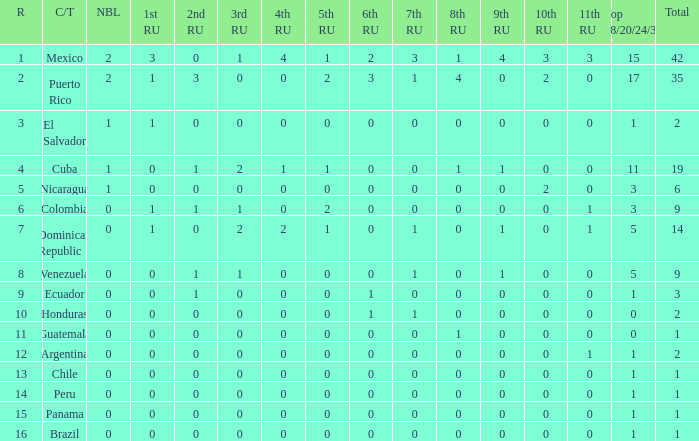What is the average total of the country with a 4th runner-up of 0 and a Nuestra Bellaza Latina less than 0? None. Give me the full table as a dictionary. {'header': ['R', 'C/T', 'NBL', '1st RU', '2nd RU', '3rd RU', '4th RU', '5th RU', '6th RU', '7th RU', '8th RU', '9th RU', '10th RU', '11th RU', 'Top 18/20/24/30', 'Total'], 'rows': [['1', 'Mexico', '2', '3', '0', '1', '4', '1', '2', '3', '1', '4', '3', '3', '15', '42'], ['2', 'Puerto Rico', '2', '1', '3', '0', '0', '2', '3', '1', '4', '0', '2', '0', '17', '35'], ['3', 'El Salvador', '1', '1', '0', '0', '0', '0', '0', '0', '0', '0', '0', '0', '1', '2'], ['4', 'Cuba', '1', '0', '1', '2', '1', '1', '0', '0', '1', '1', '0', '0', '11', '19'], ['5', 'Nicaragua', '1', '0', '0', '0', '0', '0', '0', '0', '0', '0', '2', '0', '3', '6'], ['6', 'Colombia', '0', '1', '1', '1', '0', '2', '0', '0', '0', '0', '0', '1', '3', '9'], ['7', 'Dominican Republic', '0', '1', '0', '2', '2', '1', '0', '1', '0', '1', '0', '1', '5', '14'], ['8', 'Venezuela', '0', '0', '1', '1', '0', '0', '0', '1', '0', '1', '0', '0', '5', '9'], ['9', 'Ecuador', '0', '0', '1', '0', '0', '0', '1', '0', '0', '0', '0', '0', '1', '3'], ['10', 'Honduras', '0', '0', '0', '0', '0', '0', '1', '1', '0', '0', '0', '0', '0', '2'], ['11', 'Guatemala', '0', '0', '0', '0', '0', '0', '0', '0', '1', '0', '0', '0', '0', '1'], ['12', 'Argentina', '0', '0', '0', '0', '0', '0', '0', '0', '0', '0', '0', '1', '1', '2'], ['13', 'Chile', '0', '0', '0', '0', '0', '0', '0', '0', '0', '0', '0', '0', '1', '1'], ['14', 'Peru', '0', '0', '0', '0', '0', '0', '0', '0', '0', '0', '0', '0', '1', '1'], ['15', 'Panama', '0', '0', '0', '0', '0', '0', '0', '0', '0', '0', '0', '0', '1', '1'], ['16', 'Brazil', '0', '0', '0', '0', '0', '0', '0', '0', '0', '0', '0', '0', '1', '1']]} 